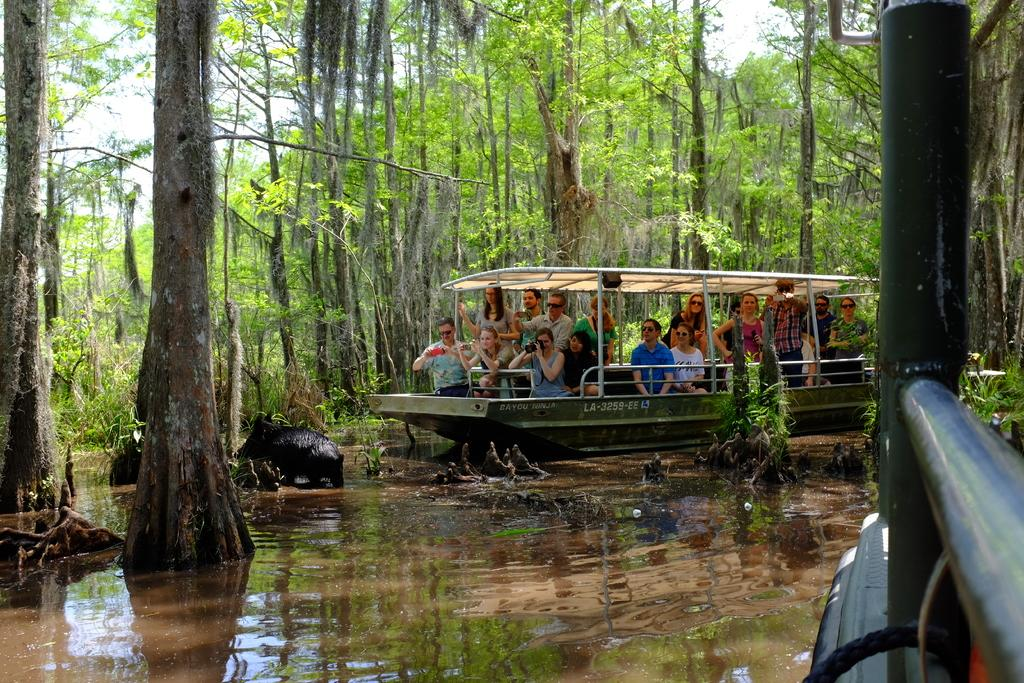What are the people in the image doing? The people in the image are in a boat. Where is the boat located? The boat is on the water. What can be seen in the background of the image? There are trees in the background of the image. What direction is the goose flying in the image? There is no goose present in the image. What type of frame is the image displayed in? The provided facts do not mention the frame of the image, so we cannot answer this question. 